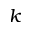Convert formula to latex. <formula><loc_0><loc_0><loc_500><loc_500>k</formula> 